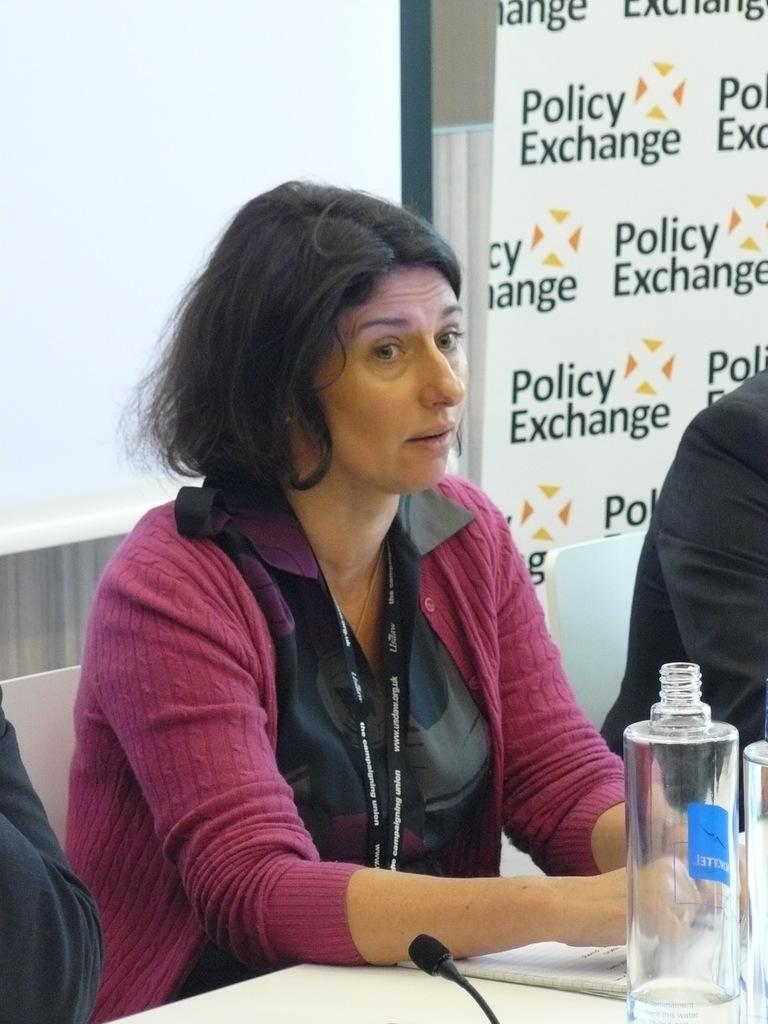<image>
Create a compact narrative representing the image presented. A woman sits at a table in front of a banned covered in Policy Exchange. 